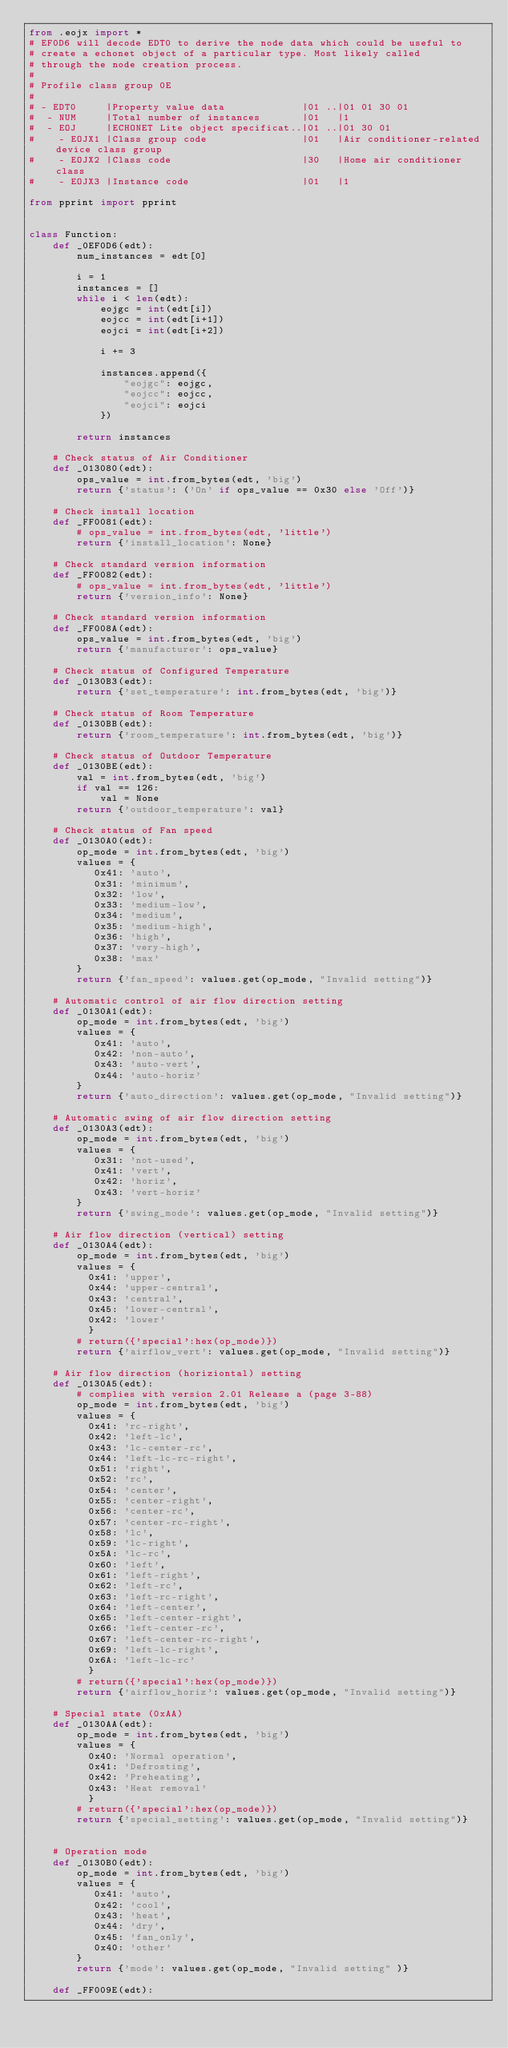Convert code to text. <code><loc_0><loc_0><loc_500><loc_500><_Python_>from .eojx import *
# EF0D6 will decode EDT0 to derive the node data which could be useful to
# create a echonet object of a particular type. Most likely called
# through the node creation process.
#
# Profile class group 0E
#
# - EDT0     |Property value data             |01 ..|01 01 30 01
#  - NUM     |Total number of instances       |01   |1
#  - EOJ     |ECHONET Lite object specificat..|01 ..|01 30 01
#    - EOJX1 |Class group code                |01   |Air conditioner-related device class group
#    - EOJX2 |Class code                      |30   |Home air conditioner class
#    - EOJX3 |Instance code                   |01   |1

from pprint import pprint


class Function:
    def _0EF0D6(edt):
        num_instances = edt[0]

        i = 1
        instances = []
        while i < len(edt):
            eojgc = int(edt[i])
            eojcc = int(edt[i+1])
            eojci = int(edt[i+2])

            i += 3

            instances.append({
                "eojgc": eojgc,
                "eojcc": eojcc,
                "eojci": eojci
            })

        return instances

    # Check status of Air Conditioner
    def _013080(edt):
        ops_value = int.from_bytes(edt, 'big')
        return {'status': ('On' if ops_value == 0x30 else 'Off')}

    # Check install location
    def _FF0081(edt):
        # ops_value = int.from_bytes(edt, 'little')
        return {'install_location': None}

    # Check standard version information
    def _FF0082(edt):
        # ops_value = int.from_bytes(edt, 'little')
        return {'version_info': None}

    # Check standard version information
    def _FF008A(edt):
        ops_value = int.from_bytes(edt, 'big')
        return {'manufacturer': ops_value}

    # Check status of Configured Temperature
    def _0130B3(edt):
        return {'set_temperature': int.from_bytes(edt, 'big')}

    # Check status of Room Temperature
    def _0130BB(edt):
        return {'room_temperature': int.from_bytes(edt, 'big')}

    # Check status of Outdoor Temperature
    def _0130BE(edt):
        val = int.from_bytes(edt, 'big')
        if val == 126: 
            val = None
        return {'outdoor_temperature': val}

    # Check status of Fan speed
    def _0130A0(edt):
        op_mode = int.from_bytes(edt, 'big')
        values = {
           0x41: 'auto',
           0x31: 'minimum',
           0x32: 'low',
           0x33: 'medium-low',
           0x34: 'medium',
           0x35: 'medium-high',
           0x36: 'high',
           0x37: 'very-high',
           0x38: 'max'
        }
        return {'fan_speed': values.get(op_mode, "Invalid setting")}

    # Automatic control of air flow direction setting
    def _0130A1(edt):
        op_mode = int.from_bytes(edt, 'big')
        values = {
           0x41: 'auto',
           0x42: 'non-auto',
           0x43: 'auto-vert',
           0x44: 'auto-horiz'
        }
        return {'auto_direction': values.get(op_mode, "Invalid setting")}

    # Automatic swing of air flow direction setting
    def _0130A3(edt):
        op_mode = int.from_bytes(edt, 'big')
        values = {
           0x31: 'not-used',
           0x41: 'vert',
           0x42: 'horiz',
           0x43: 'vert-horiz'
        }
        return {'swing_mode': values.get(op_mode, "Invalid setting")}

    # Air flow direction (vertical) setting
    def _0130A4(edt):
        op_mode = int.from_bytes(edt, 'big')
        values = {
          0x41: 'upper',
          0x44: 'upper-central',
          0x43: 'central',
          0x45: 'lower-central',
          0x42: 'lower'
          }
        # return({'special':hex(op_mode)})
        return {'airflow_vert': values.get(op_mode, "Invalid setting")}

    # Air flow direction (horiziontal) setting
    def _0130A5(edt):
        # complies with version 2.01 Release a (page 3-88)
        op_mode = int.from_bytes(edt, 'big')
        values = {
          0x41: 'rc-right',
          0x42: 'left-lc',
          0x43: 'lc-center-rc',
          0x44: 'left-lc-rc-right',
          0x51: 'right',
          0x52: 'rc',
          0x54: 'center',
          0x55: 'center-right',
          0x56: 'center-rc',
          0x57: 'center-rc-right',
          0x58: 'lc',
          0x59: 'lc-right',
          0x5A: 'lc-rc',
          0x60: 'left',
          0x61: 'left-right',
          0x62: 'left-rc',
          0x63: 'left-rc-right',
          0x64: 'left-center',
          0x65: 'left-center-right',
          0x66: 'left-center-rc',
          0x67: 'left-center-rc-right',
          0x69: 'left-lc-right',
          0x6A: 'left-lc-rc'
          }
        # return({'special':hex(op_mode)})
        return {'airflow_horiz': values.get(op_mode, "Invalid setting")}

    # Special state (0xAA)
    def _0130AA(edt):
        op_mode = int.from_bytes(edt, 'big')
        values = {
          0x40: 'Normal operation',
          0x41: 'Defrosting',
          0x42: 'Preheating',
          0x43: 'Heat removal'
          }
        # return({'special':hex(op_mode)})
        return {'special_setting': values.get(op_mode, "Invalid setting")}


    # Operation mode
    def _0130B0(edt):
        op_mode = int.from_bytes(edt, 'big')
        values = {
           0x41: 'auto',
           0x42: 'cool',
           0x43: 'heat',
           0x44: 'dry',
           0x45: 'fan_only',
           0x40: 'other'
        }
        return {'mode': values.get(op_mode, "Invalid setting" )}

    def _FF009E(edt):</code> 